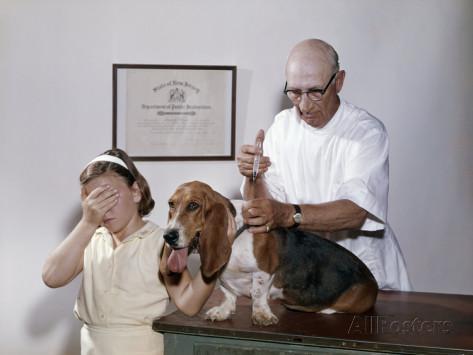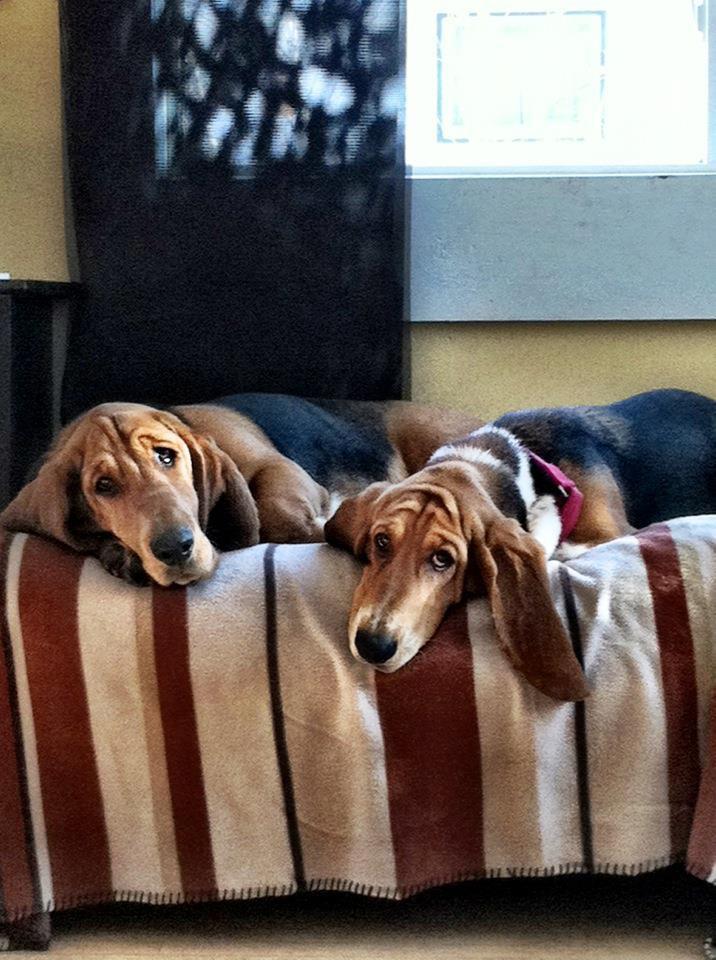The first image is the image on the left, the second image is the image on the right. Analyze the images presented: Is the assertion "There are more than three dogs on the left, and one dog on the right." valid? Answer yes or no. No. The first image is the image on the left, the second image is the image on the right. Evaluate the accuracy of this statement regarding the images: "In one of the pictures a dog is standing on its hind legs.". Is it true? Answer yes or no. No. 